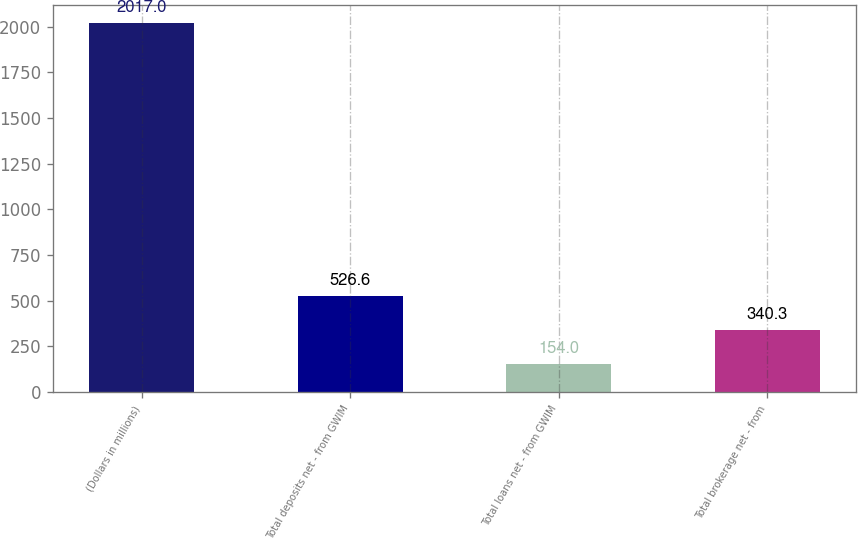Convert chart to OTSL. <chart><loc_0><loc_0><loc_500><loc_500><bar_chart><fcel>(Dollars in millions)<fcel>Total deposits net - from GWIM<fcel>Total loans net - from GWIM<fcel>Total brokerage net - from<nl><fcel>2017<fcel>526.6<fcel>154<fcel>340.3<nl></chart> 